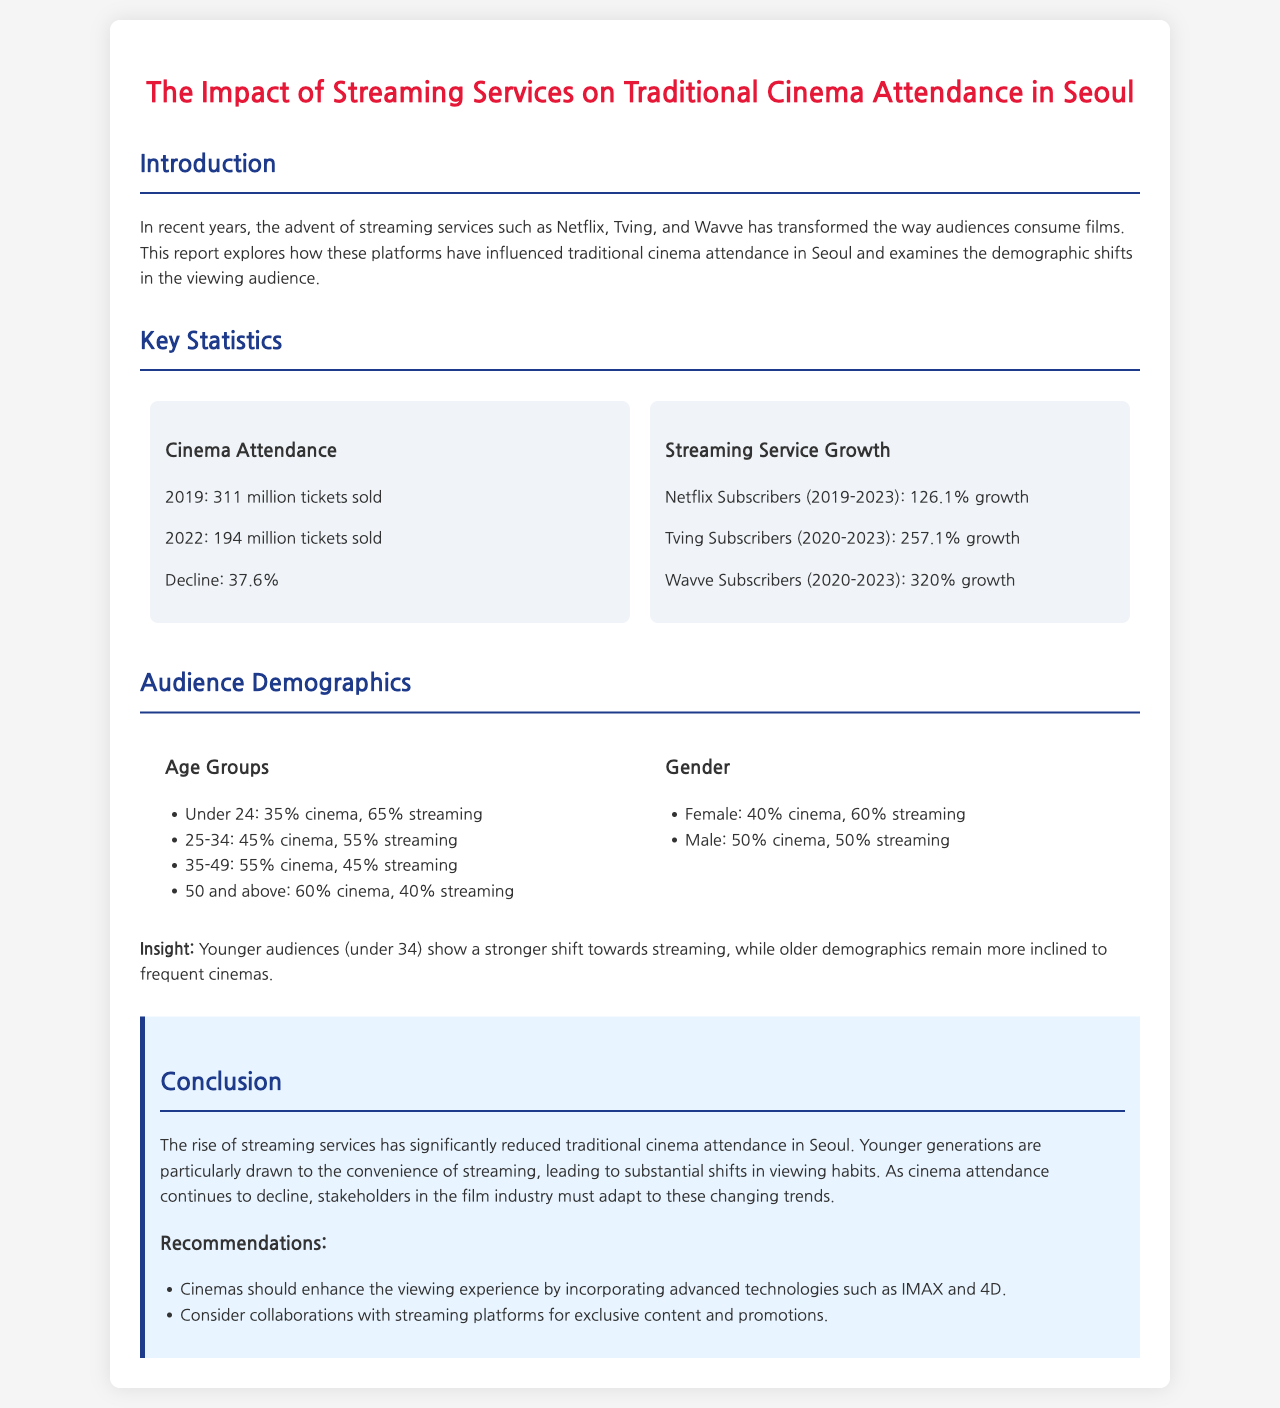What was the number of cinema tickets sold in 2019? The document states that 311 million tickets were sold in 2019.
Answer: 311 million What was the percentage decline in cinema attendance from 2019 to 2022? The report indicates a decline of 37.6%.
Answer: 37.6% How much did Netflix subscribers grow from 2019 to 2023? The report mentions a growth of 126.1% for Netflix subscribers in that period.
Answer: 126.1% Which age group shows the highest percentage of cinema attendance? The document indicates that the 50 and above age group has the highest cinema attendance at 60%.
Answer: 60% What percentage of females prefer streaming over cinema? The report states that 60% of females prefer streaming compared to cinema.
Answer: 60% Which demographic is more inclined to frequent cinemas according to the report? The older demographic, particularly those aged 50 and above, are indicated to be more inclined to frequent cinemas.
Answer: Older demographic What recommendation does the report give for enhancing the cinema experience? The report suggests incorporating advanced technologies such as IMAX and 4D for better viewing experiences.
Answer: IMAX and 4D What was the number of cinema tickets sold in 2022? The document reports that 194 million tickets were sold in 2022.
Answer: 194 million Which streaming service had the highest percentage growth according to the report? The report indicates that Wavve had the highest subscription growth at 320%.
Answer: 320% 